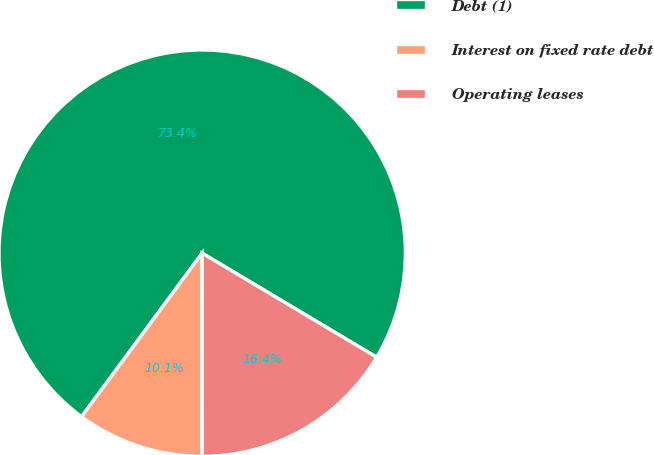Convert chart. <chart><loc_0><loc_0><loc_500><loc_500><pie_chart><fcel>Debt (1)<fcel>Interest on fixed rate debt<fcel>Operating leases<nl><fcel>73.44%<fcel>10.11%<fcel>16.44%<nl></chart> 